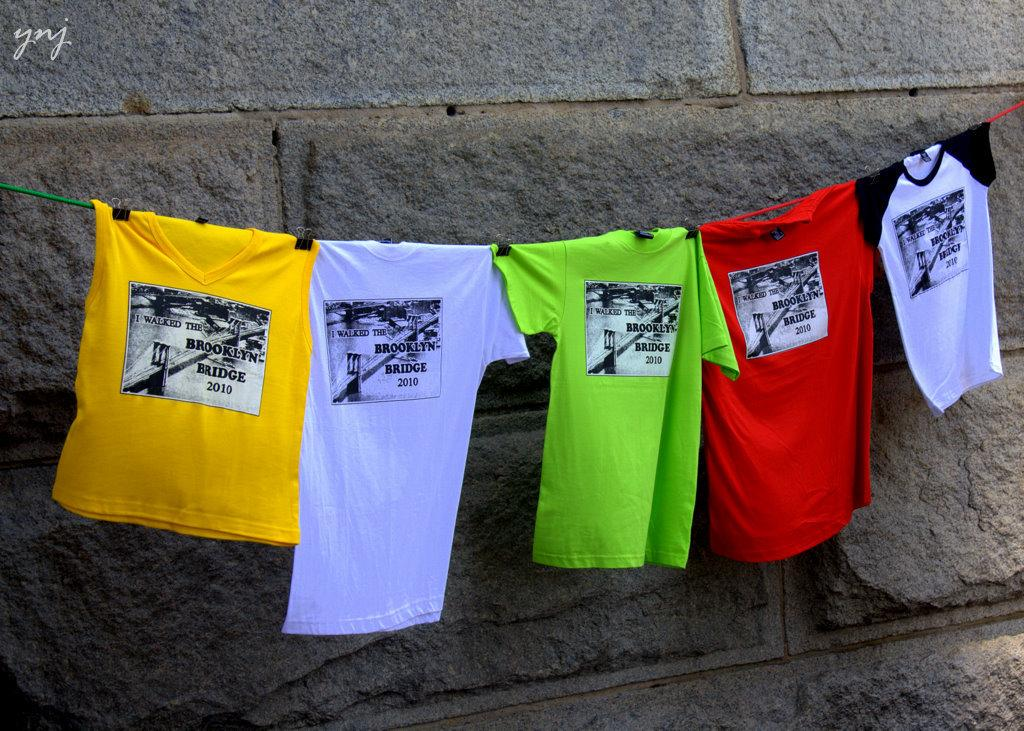<image>
Summarize the visual content of the image. Tshirts with the words "I walked the Brooklyn Bridge" on the front of them, hanging on a clothesline in front of a building. 